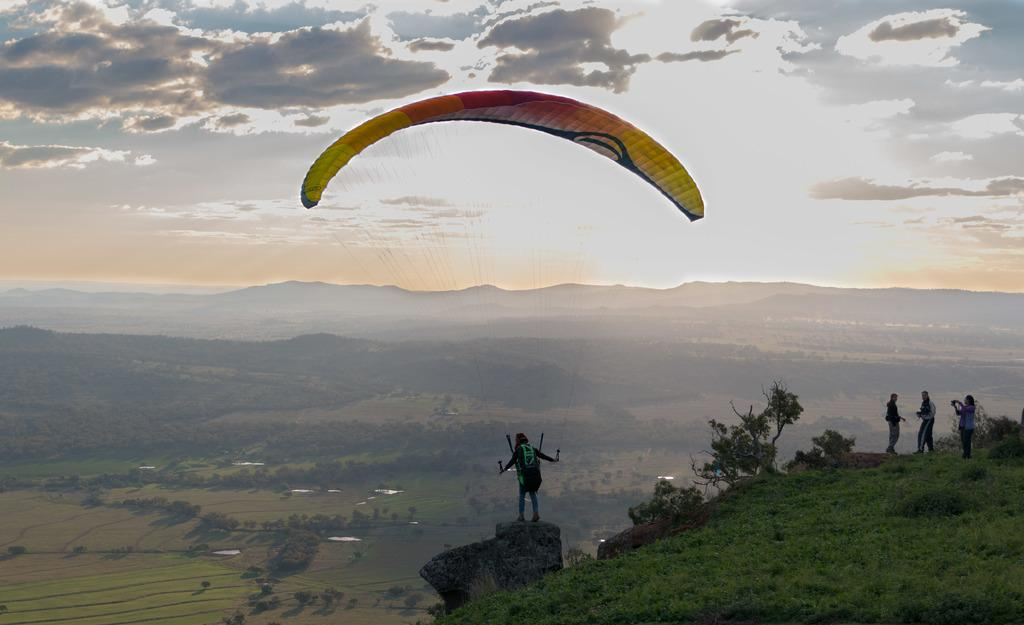Who or what is present in the image? There are people in the image. What type of terrain is visible in the image? There is grass and a hill in the image. What activity can be seen in the image? Paragliding is visible in the image. What is the condition of the sky in the background of the image? The background of the image includes a cloudy sky. What type of vegetation is present in the image? There are plants in the image. What type of knowledge can be gained from the bead in the image? There is no bead present in the image, so no knowledge can be gained from it. 